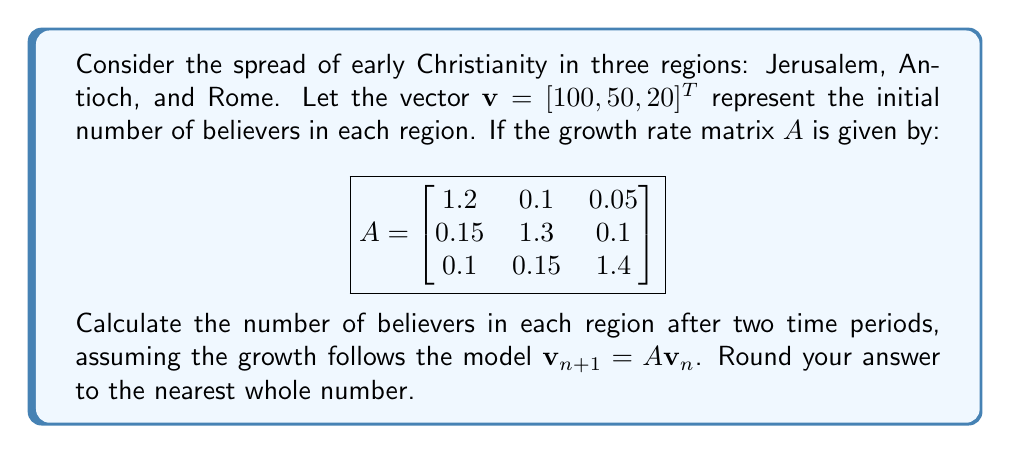What is the answer to this math problem? To solve this problem, we need to apply the growth matrix $A$ twice to the initial vector $\mathbf{v}$. This represents the spread of Christianity over two time periods.

Step 1: Calculate $\mathbf{v}_1 = A\mathbf{v}$

$$\mathbf{v}_1 = \begin{bmatrix}
1.2 & 0.1 & 0.05 \\
0.15 & 1.3 & 0.1 \\
0.1 & 0.15 & 1.4
\end{bmatrix} \begin{bmatrix}
100 \\
50 \\
20
\end{bmatrix}$$

$$\mathbf{v}_1 = \begin{bmatrix}
(1.2 \times 100) + (0.1 \times 50) + (0.05 \times 20) \\
(0.15 \times 100) + (1.3 \times 50) + (0.1 \times 20) \\
(0.1 \times 100) + (0.15 \times 50) + (1.4 \times 20)
\end{bmatrix}$$

$$\mathbf{v}_1 = \begin{bmatrix}
126 \\
82.5 \\
45
\end{bmatrix}$$

Step 2: Calculate $\mathbf{v}_2 = A\mathbf{v}_1$

$$\mathbf{v}_2 = \begin{bmatrix}
1.2 & 0.1 & 0.05 \\
0.15 & 1.3 & 0.1 \\
0.1 & 0.15 & 1.4
\end{bmatrix} \begin{bmatrix}
126 \\
82.5 \\
45
\end{bmatrix}$$

$$\mathbf{v}_2 = \begin{bmatrix}
(1.2 \times 126) + (0.1 \times 82.5) + (0.05 \times 45) \\
(0.15 \times 126) + (1.3 \times 82.5) + (0.1 \times 45) \\
(0.1 \times 126) + (0.15 \times 82.5) + (1.4 \times 45)
\end{bmatrix}$$

$$\mathbf{v}_2 = \begin{bmatrix}
160.575 \\
131.625 \\
82.875
\end{bmatrix}$$

Step 3: Round the results to the nearest whole number

$$\mathbf{v}_2 \approx \begin{bmatrix}
161 \\
132 \\
83
\end{bmatrix}$$

This final vector represents the number of believers in Jerusalem, Antioch, and Rome, respectively, after two time periods.
Answer: $[161, 132, 83]^T$ 